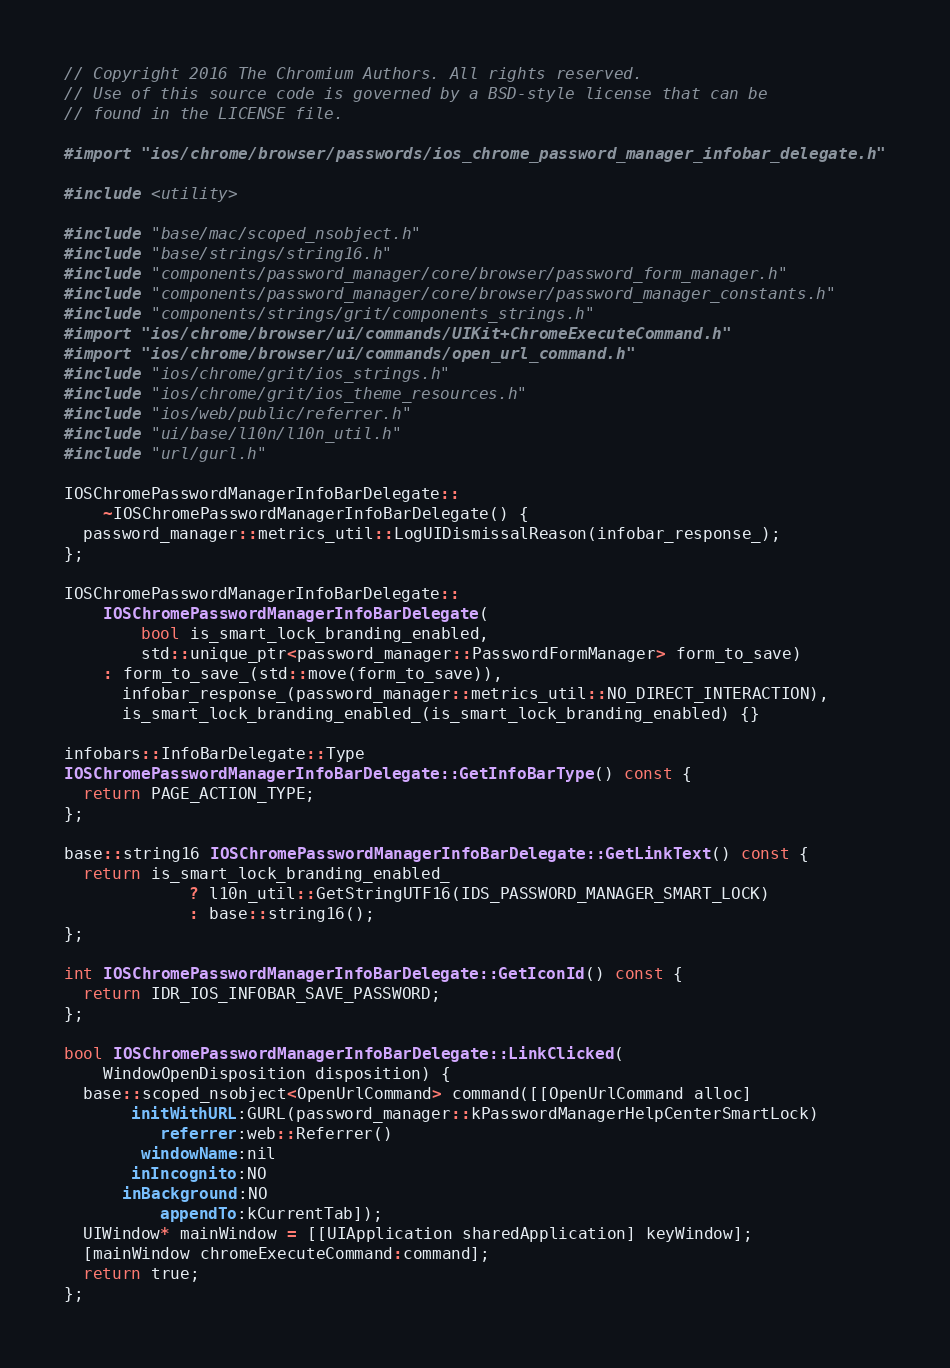Convert code to text. <code><loc_0><loc_0><loc_500><loc_500><_ObjectiveC_>// Copyright 2016 The Chromium Authors. All rights reserved.
// Use of this source code is governed by a BSD-style license that can be
// found in the LICENSE file.

#import "ios/chrome/browser/passwords/ios_chrome_password_manager_infobar_delegate.h"

#include <utility>

#include "base/mac/scoped_nsobject.h"
#include "base/strings/string16.h"
#include "components/password_manager/core/browser/password_form_manager.h"
#include "components/password_manager/core/browser/password_manager_constants.h"
#include "components/strings/grit/components_strings.h"
#import "ios/chrome/browser/ui/commands/UIKit+ChromeExecuteCommand.h"
#import "ios/chrome/browser/ui/commands/open_url_command.h"
#include "ios/chrome/grit/ios_strings.h"
#include "ios/chrome/grit/ios_theme_resources.h"
#include "ios/web/public/referrer.h"
#include "ui/base/l10n/l10n_util.h"
#include "url/gurl.h"

IOSChromePasswordManagerInfoBarDelegate::
    ~IOSChromePasswordManagerInfoBarDelegate() {
  password_manager::metrics_util::LogUIDismissalReason(infobar_response_);
};

IOSChromePasswordManagerInfoBarDelegate::
    IOSChromePasswordManagerInfoBarDelegate(
        bool is_smart_lock_branding_enabled,
        std::unique_ptr<password_manager::PasswordFormManager> form_to_save)
    : form_to_save_(std::move(form_to_save)),
      infobar_response_(password_manager::metrics_util::NO_DIRECT_INTERACTION),
      is_smart_lock_branding_enabled_(is_smart_lock_branding_enabled) {}

infobars::InfoBarDelegate::Type
IOSChromePasswordManagerInfoBarDelegate::GetInfoBarType() const {
  return PAGE_ACTION_TYPE;
};

base::string16 IOSChromePasswordManagerInfoBarDelegate::GetLinkText() const {
  return is_smart_lock_branding_enabled_
             ? l10n_util::GetStringUTF16(IDS_PASSWORD_MANAGER_SMART_LOCK)
             : base::string16();
};

int IOSChromePasswordManagerInfoBarDelegate::GetIconId() const {
  return IDR_IOS_INFOBAR_SAVE_PASSWORD;
};

bool IOSChromePasswordManagerInfoBarDelegate::LinkClicked(
    WindowOpenDisposition disposition) {
  base::scoped_nsobject<OpenUrlCommand> command([[OpenUrlCommand alloc]
       initWithURL:GURL(password_manager::kPasswordManagerHelpCenterSmartLock)
          referrer:web::Referrer()
        windowName:nil
       inIncognito:NO
      inBackground:NO
          appendTo:kCurrentTab]);
  UIWindow* mainWindow = [[UIApplication sharedApplication] keyWindow];
  [mainWindow chromeExecuteCommand:command];
  return true;
};
</code> 